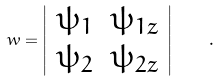<formula> <loc_0><loc_0><loc_500><loc_500>w = \left | \begin{array} { l l } \psi _ { 1 } & \psi _ { 1 z } \\ \psi _ { 2 } & \psi _ { 2 z } \end{array} \right | \quad .</formula> 